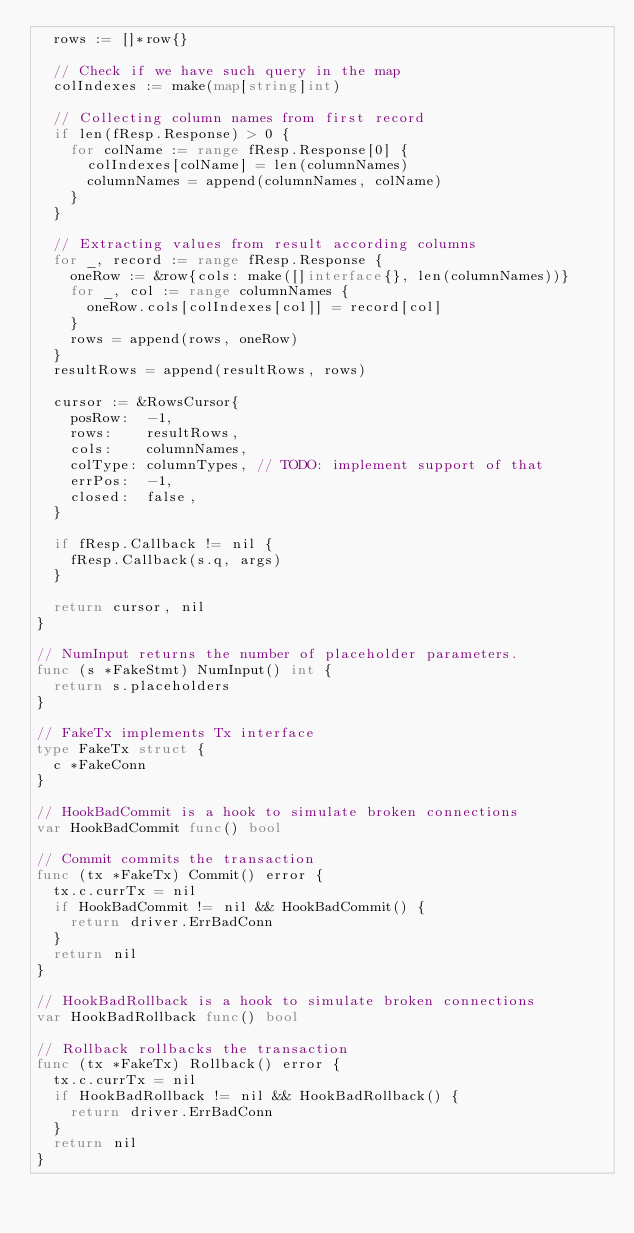Convert code to text. <code><loc_0><loc_0><loc_500><loc_500><_Go_>	rows := []*row{}

	// Check if we have such query in the map
	colIndexes := make(map[string]int)

	// Collecting column names from first record
	if len(fResp.Response) > 0 {
		for colName := range fResp.Response[0] {
			colIndexes[colName] = len(columnNames)
			columnNames = append(columnNames, colName)
		}
	}

	// Extracting values from result according columns
	for _, record := range fResp.Response {
		oneRow := &row{cols: make([]interface{}, len(columnNames))}
		for _, col := range columnNames {
			oneRow.cols[colIndexes[col]] = record[col]
		}
		rows = append(rows, oneRow)
	}
	resultRows = append(resultRows, rows)

	cursor := &RowsCursor{
		posRow:  -1,
		rows:    resultRows,
		cols:    columnNames,
		colType: columnTypes, // TODO: implement support of that
		errPos:  -1,
		closed:  false,
	}

	if fResp.Callback != nil {
		fResp.Callback(s.q, args)
	}

	return cursor, nil
}

// NumInput returns the number of placeholder parameters.
func (s *FakeStmt) NumInput() int {
	return s.placeholders
}

// FakeTx implements Tx interface
type FakeTx struct {
	c *FakeConn
}

// HookBadCommit is a hook to simulate broken connections
var HookBadCommit func() bool

// Commit commits the transaction
func (tx *FakeTx) Commit() error {
	tx.c.currTx = nil
	if HookBadCommit != nil && HookBadCommit() {
		return driver.ErrBadConn
	}
	return nil
}

// HookBadRollback is a hook to simulate broken connections
var HookBadRollback func() bool

// Rollback rollbacks the transaction
func (tx *FakeTx) Rollback() error {
	tx.c.currTx = nil
	if HookBadRollback != nil && HookBadRollback() {
		return driver.ErrBadConn
	}
	return nil
}
</code> 